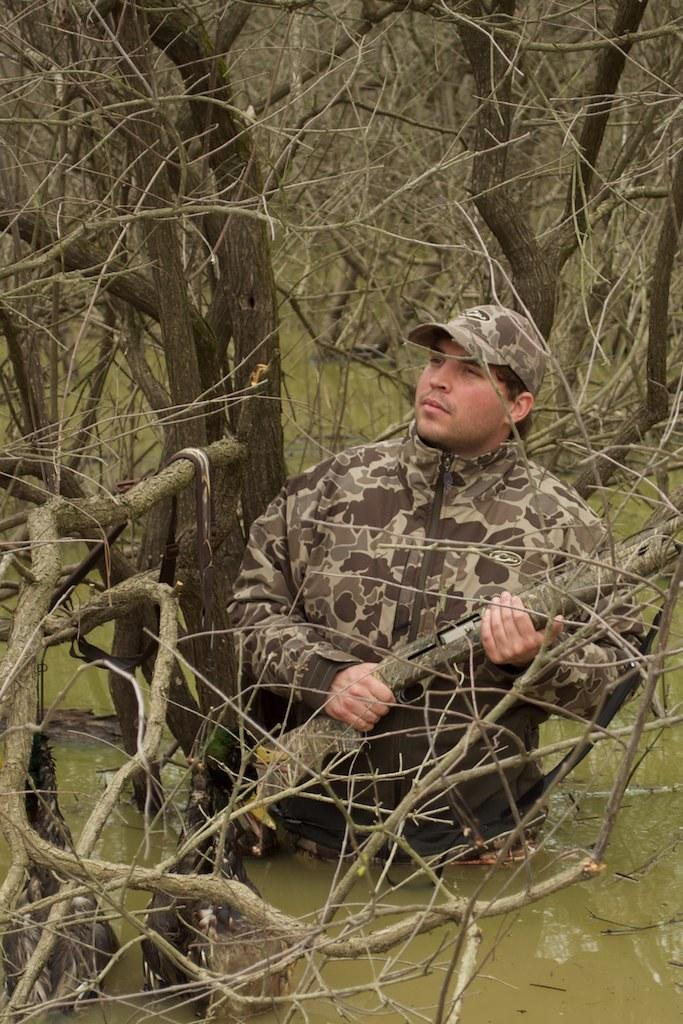What is the man in the image doing? The man is standing in the water. What is the man holding in his hand? The man is holding a gun in his hand. What type of headwear is the man wearing? The man is wearing a cap. What type of clothing is the man wearing? The man is wearing a uniform. What can be seen in the background of the image? There are trees and water visible in the background. What type of crown is the man wearing in the image? There is no crown present in the image; the man is wearing a cap. What is the man pointing at in the image? The man is not pointing at anything in the image; he is holding a gun in his hand. 